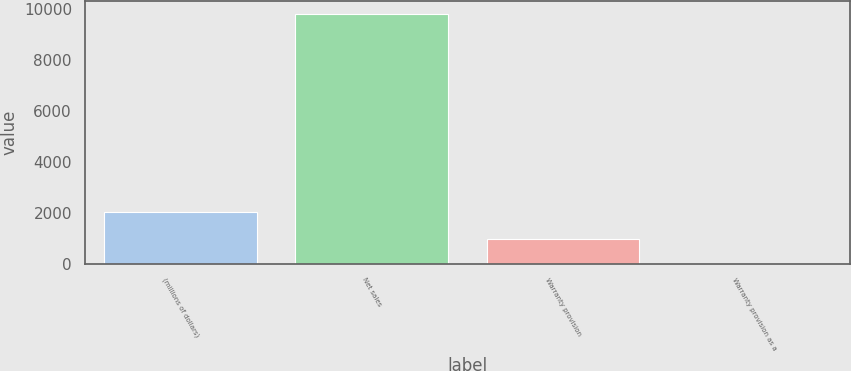Convert chart to OTSL. <chart><loc_0><loc_0><loc_500><loc_500><bar_chart><fcel>(millions of dollars)<fcel>Net sales<fcel>Warranty provision<fcel>Warranty provision as a<nl><fcel>2017<fcel>9799.3<fcel>980.56<fcel>0.7<nl></chart> 